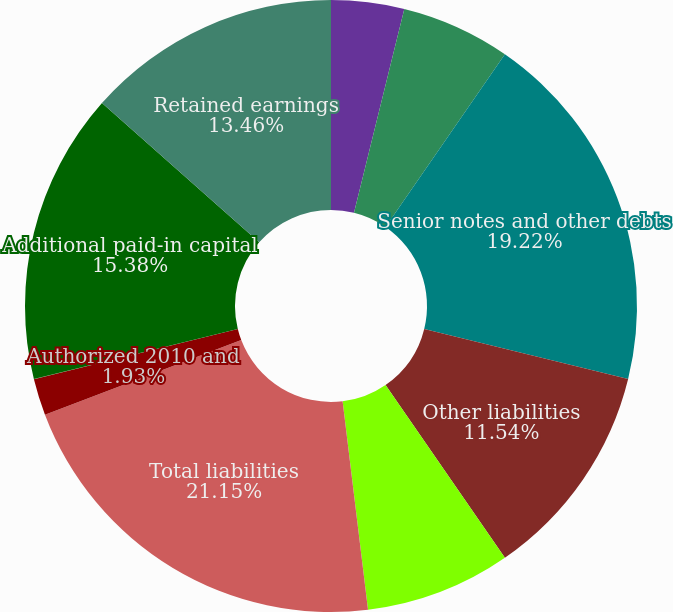Convert chart. <chart><loc_0><loc_0><loc_500><loc_500><pie_chart><fcel>Accounts payable<fcel>Liabilities related to<fcel>Senior notes and other debts<fcel>Other liabilities<fcel>Lennar Financial Services<fcel>Total liabilities<fcel>Authorized 2010 and<fcel>Issued 2010-32970914 shares<fcel>Additional paid-in capital<fcel>Retained earnings<nl><fcel>3.85%<fcel>5.77%<fcel>19.22%<fcel>11.54%<fcel>7.69%<fcel>21.15%<fcel>1.93%<fcel>0.01%<fcel>15.38%<fcel>13.46%<nl></chart> 